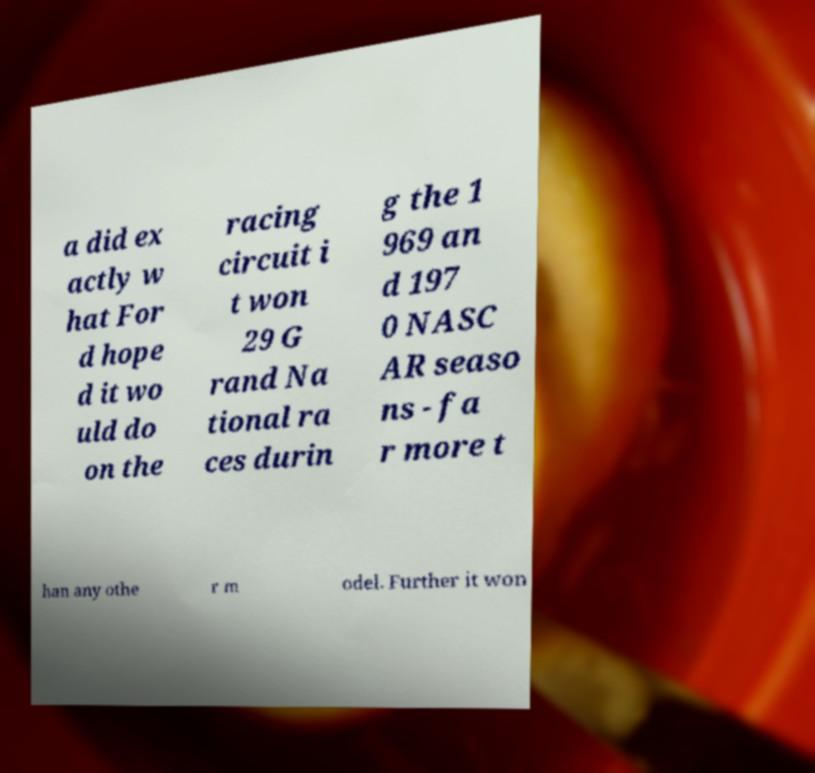Please identify and transcribe the text found in this image. a did ex actly w hat For d hope d it wo uld do on the racing circuit i t won 29 G rand Na tional ra ces durin g the 1 969 an d 197 0 NASC AR seaso ns - fa r more t han any othe r m odel. Further it won 